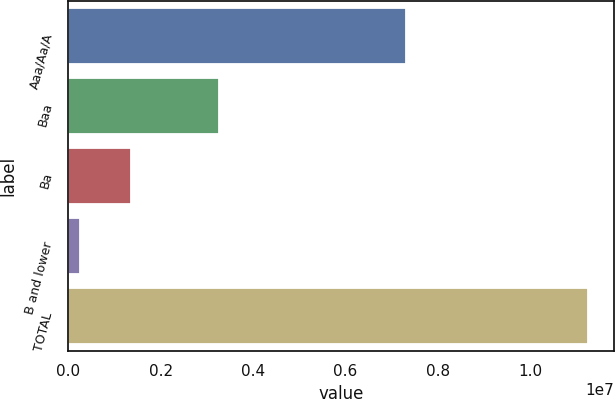Convert chart. <chart><loc_0><loc_0><loc_500><loc_500><bar_chart><fcel>Aaa/Aa/A<fcel>Baa<fcel>Ba<fcel>B and lower<fcel>TOTAL<nl><fcel>7.31421e+06<fcel>3.2555e+06<fcel>1.36145e+06<fcel>261258<fcel>1.12632e+07<nl></chart> 